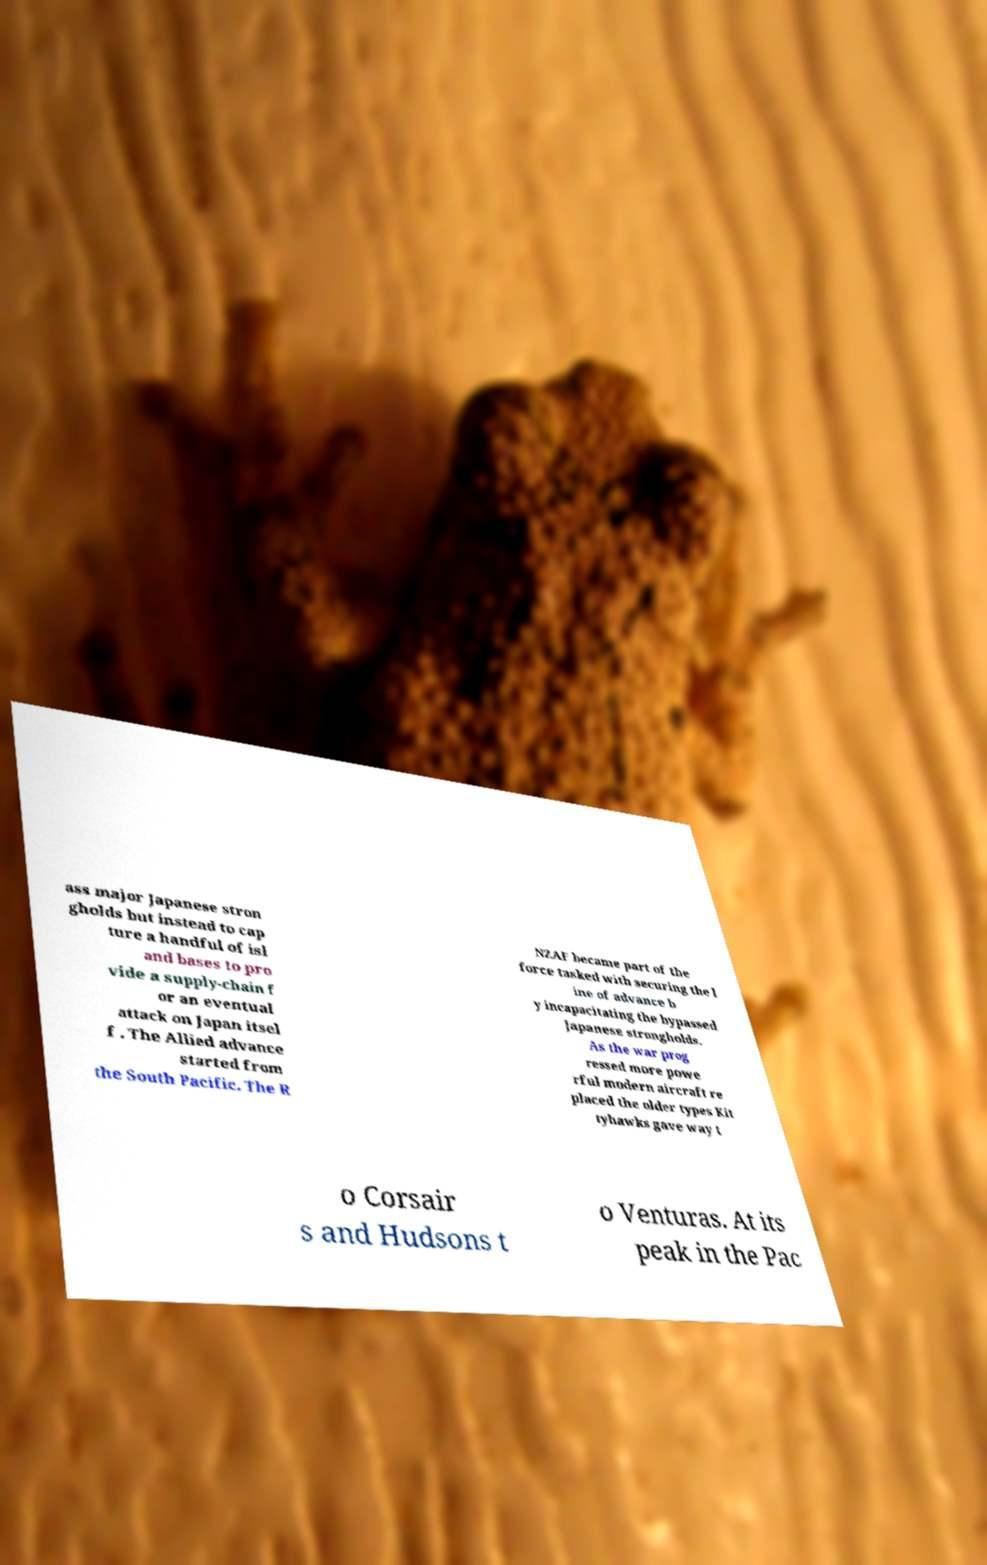Could you extract and type out the text from this image? ass major Japanese stron gholds but instead to cap ture a handful of isl and bases to pro vide a supply-chain f or an eventual attack on Japan itsel f . The Allied advance started from the South Pacific. The R NZAF became part of the force tasked with securing the l ine of advance b y incapacitating the bypassed Japanese strongholds. As the war prog ressed more powe rful modern aircraft re placed the older types Kit tyhawks gave way t o Corsair s and Hudsons t o Venturas. At its peak in the Pac 